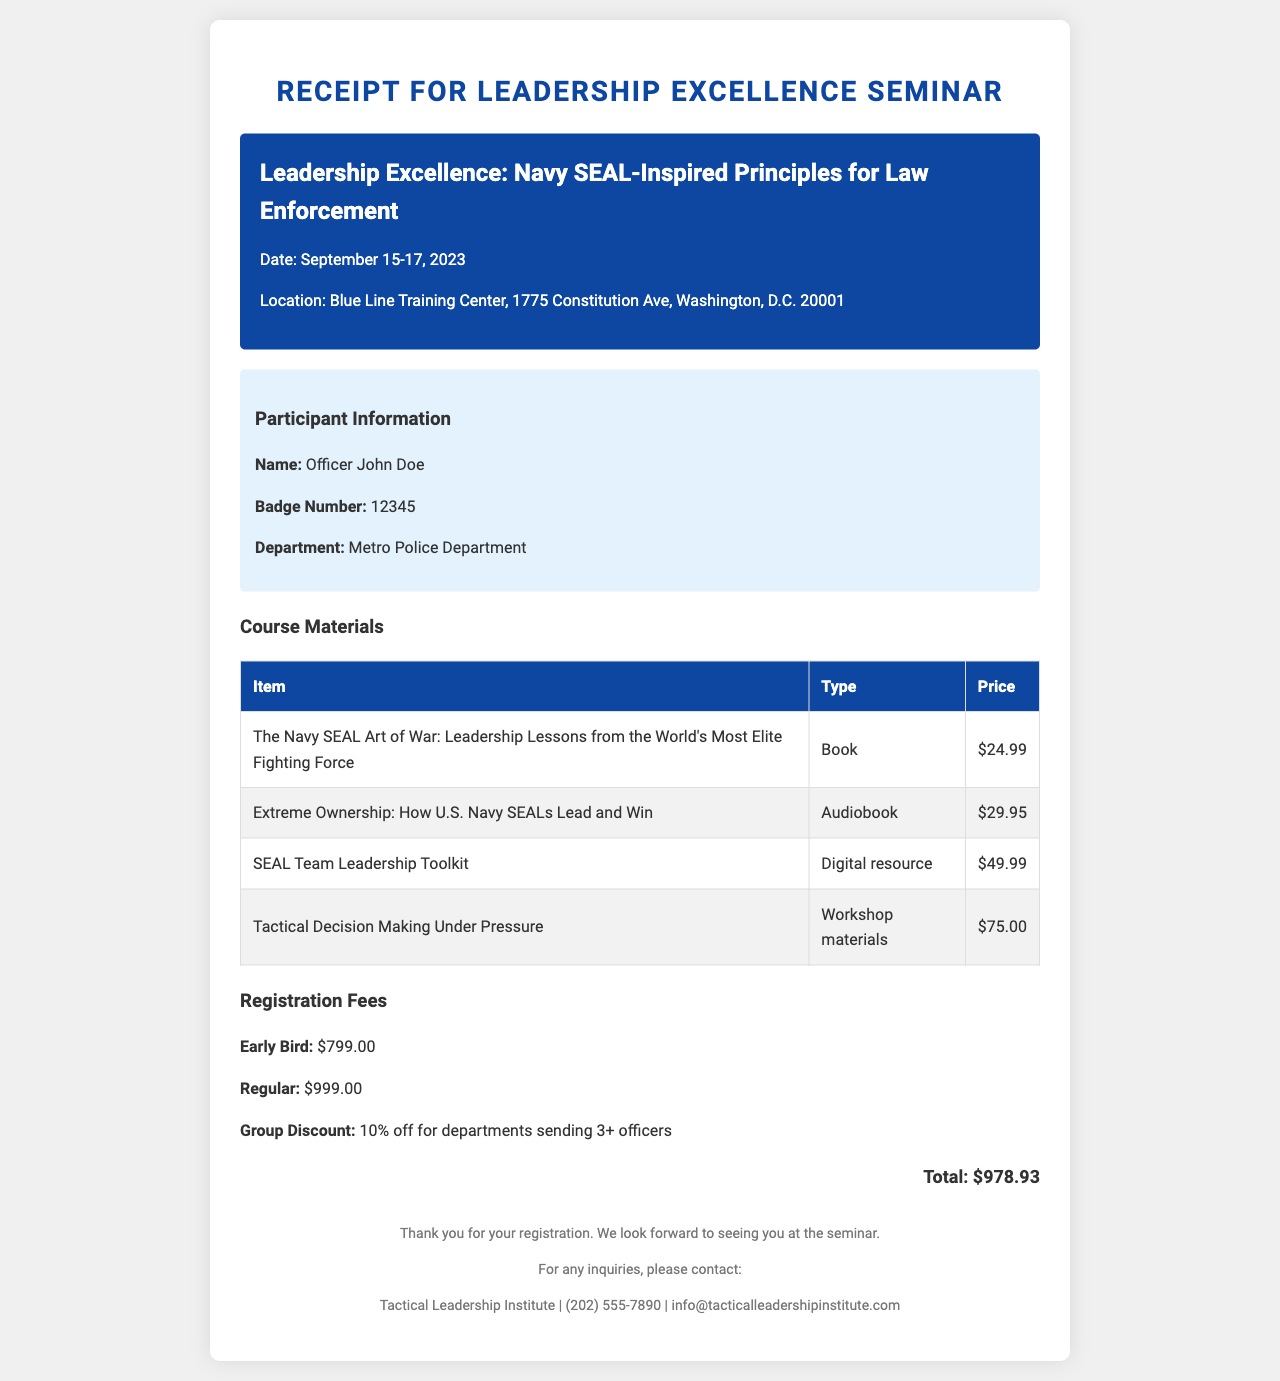what is the seminar name? The seminar name is stated clearly in the document as the title.
Answer: Leadership Excellence: Navy SEAL-Inspired Principles for Law Enforcement when is the seminar date? The seminar date is provided in the document along with the seminar name.
Answer: September 15-17, 2023 where is the seminar located? The location of the seminar is described in the document.
Answer: Blue Line Training Center, 1775 Constitution Ave, Washington, D.C. 20001 who is the participant? Information about the participant includes their name, badge number, and department.
Answer: Officer John Doe what are the course materials included? The document lists specific items as course materials, including types and prices.
Answer: The Navy SEAL Art of War, Extreme Ownership, SEAL Team Leadership Toolkit, Tactical Decision Making Under Pressure what is the group discount? The group discount information is accessible in the registration section of the document.
Answer: 10% off for departments sending 3+ officers how many continuing education credits are offered? The number of credits is specified in the document as related to the seminar.
Answer: 24 what is the cancellation policy? The document provides details on what happens if the registration is canceled and the timeframes for refunds.
Answer: Full refund if cancelled 30 days before the event, 50% refund if cancelled 14-29 days before who are the guest speakers? Guest speakers' names and topics are mentioned in the document, showcasing their expertise.
Answer: Commander William McRaven (Ret.), Chief David Brown (Ret.) 